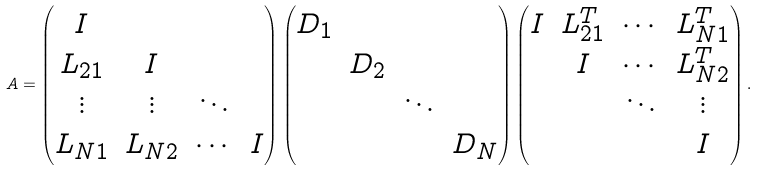<formula> <loc_0><loc_0><loc_500><loc_500>A = \begin{pmatrix} I & & & \\ L _ { 2 1 } & I & & \\ \vdots & \vdots & \ddots & \\ L _ { N 1 } & L _ { N 2 } & \cdots & I \end{pmatrix} \begin{pmatrix} D _ { 1 } & & & \\ & D _ { 2 } & & \\ & & \ddots & \\ & & & D _ { N } \end{pmatrix} \begin{pmatrix} I & L _ { 2 1 } ^ { T } & \cdots & L _ { N 1 } ^ { T } \\ & I & \cdots & L _ { N 2 } ^ { T } \\ & & \ddots & \vdots \\ & & & I \end{pmatrix} .</formula> 